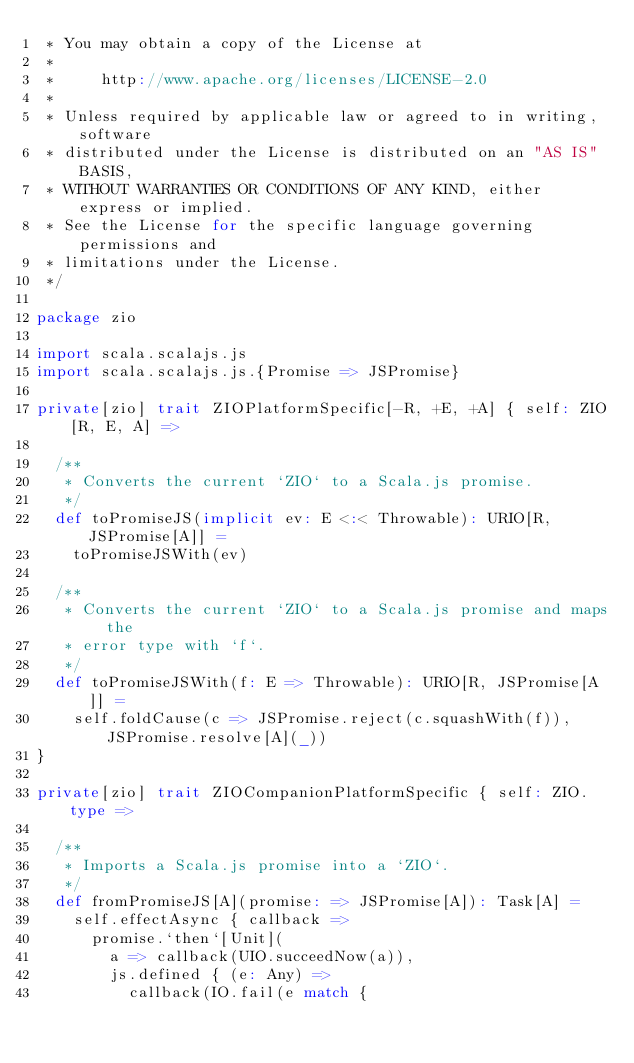<code> <loc_0><loc_0><loc_500><loc_500><_Scala_> * You may obtain a copy of the License at
 *
 *     http://www.apache.org/licenses/LICENSE-2.0
 *
 * Unless required by applicable law or agreed to in writing, software
 * distributed under the License is distributed on an "AS IS" BASIS,
 * WITHOUT WARRANTIES OR CONDITIONS OF ANY KIND, either express or implied.
 * See the License for the specific language governing permissions and
 * limitations under the License.
 */

package zio

import scala.scalajs.js
import scala.scalajs.js.{Promise => JSPromise}

private[zio] trait ZIOPlatformSpecific[-R, +E, +A] { self: ZIO[R, E, A] =>

  /**
   * Converts the current `ZIO` to a Scala.js promise.
   */
  def toPromiseJS(implicit ev: E <:< Throwable): URIO[R, JSPromise[A]] =
    toPromiseJSWith(ev)

  /**
   * Converts the current `ZIO` to a Scala.js promise and maps the
   * error type with `f`.
   */
  def toPromiseJSWith(f: E => Throwable): URIO[R, JSPromise[A]] =
    self.foldCause(c => JSPromise.reject(c.squashWith(f)), JSPromise.resolve[A](_))
}

private[zio] trait ZIOCompanionPlatformSpecific { self: ZIO.type =>

  /**
   * Imports a Scala.js promise into a `ZIO`.
   */
  def fromPromiseJS[A](promise: => JSPromise[A]): Task[A] =
    self.effectAsync { callback =>
      promise.`then`[Unit](
        a => callback(UIO.succeedNow(a)),
        js.defined { (e: Any) =>
          callback(IO.fail(e match {</code> 